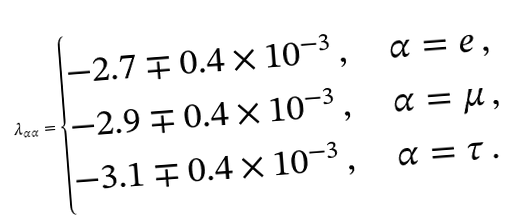<formula> <loc_0><loc_0><loc_500><loc_500>\lambda _ { \alpha \alpha } = \begin{cases} - 2 . 7 \mp 0 . 4 \times 1 0 ^ { - 3 } \, , \quad \alpha = e \, , \\ - 2 . 9 \mp 0 . 4 \times 1 0 ^ { - 3 } \, , \quad \alpha = \mu \, , \\ - 3 . 1 \mp 0 . 4 \times 1 0 ^ { - 3 } \, , \quad \alpha = \tau \, . \end{cases}</formula> 